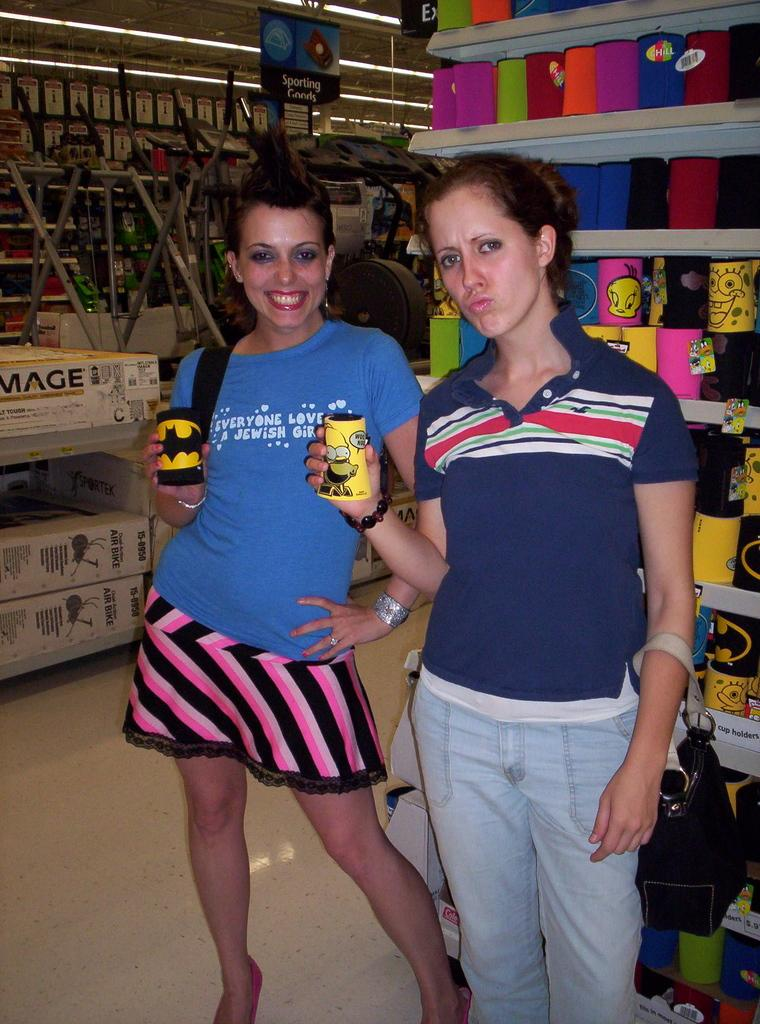<image>
Share a concise interpretation of the image provided. Two young women, one wearing a shirt reading 'everone loves a Jewish girl.' 